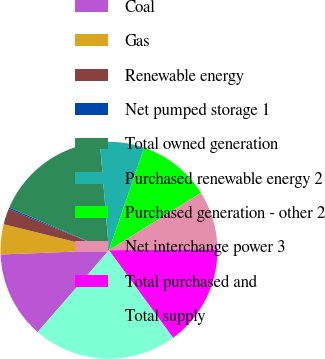Convert chart to OTSL. <chart><loc_0><loc_0><loc_500><loc_500><pie_chart><fcel>Coal<fcel>Gas<fcel>Renewable energy<fcel>Net pumped storage 1<fcel>Total owned generation<fcel>Purchased renewable energy 2<fcel>Purchased generation - other 2<fcel>Net interchange power 3<fcel>Total purchased and<fcel>Total supply<nl><fcel>12.97%<fcel>4.48%<fcel>2.35%<fcel>0.23%<fcel>17.22%<fcel>6.6%<fcel>10.85%<fcel>8.73%<fcel>15.1%<fcel>21.47%<nl></chart> 